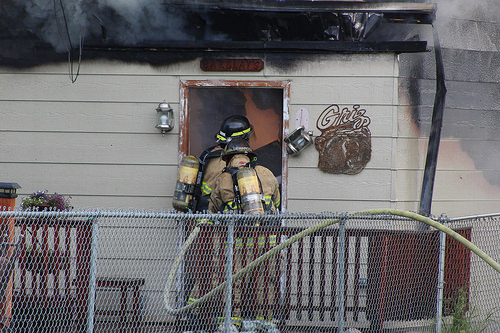<image>
Is the fireman behind the fence? Yes. From this viewpoint, the fireman is positioned behind the fence, with the fence partially or fully occluding the fireman. 